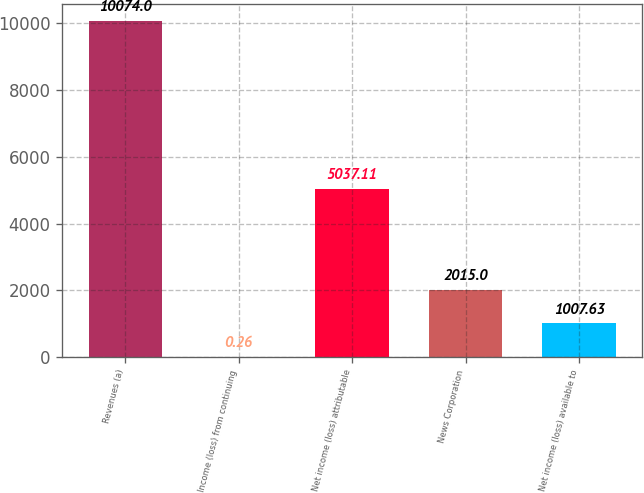Convert chart. <chart><loc_0><loc_0><loc_500><loc_500><bar_chart><fcel>Revenues (a)<fcel>Income (loss) from continuing<fcel>Net income (loss) attributable<fcel>News Corporation<fcel>Net income (loss) available to<nl><fcel>10074<fcel>0.26<fcel>5037.11<fcel>2015<fcel>1007.63<nl></chart> 